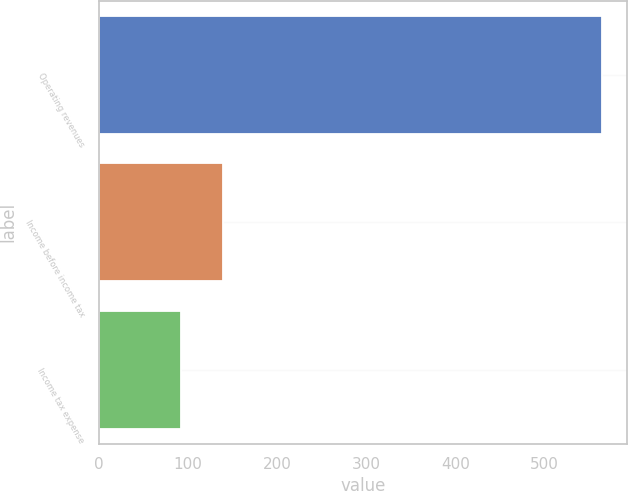Convert chart to OTSL. <chart><loc_0><loc_0><loc_500><loc_500><bar_chart><fcel>Operating revenues<fcel>Income before income tax<fcel>Income tax expense<nl><fcel>565<fcel>139.3<fcel>92<nl></chart> 